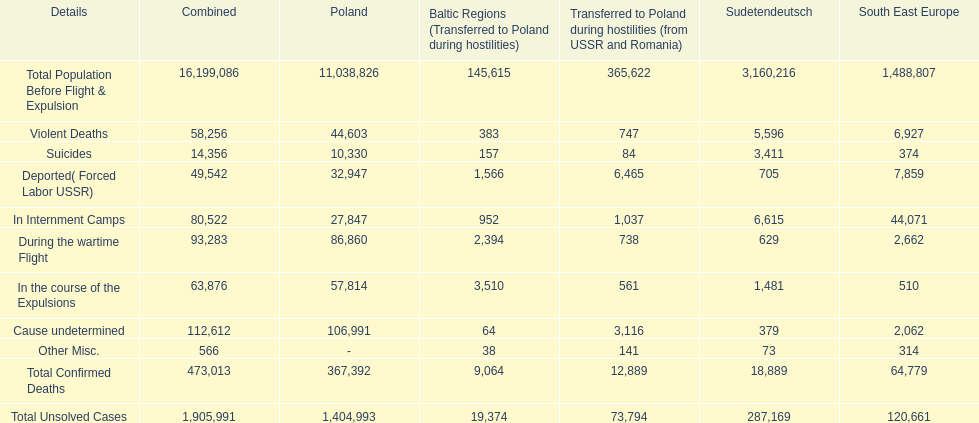Which region had the least total of unsolved cases? Baltic States(Resettled in Poland during war). 